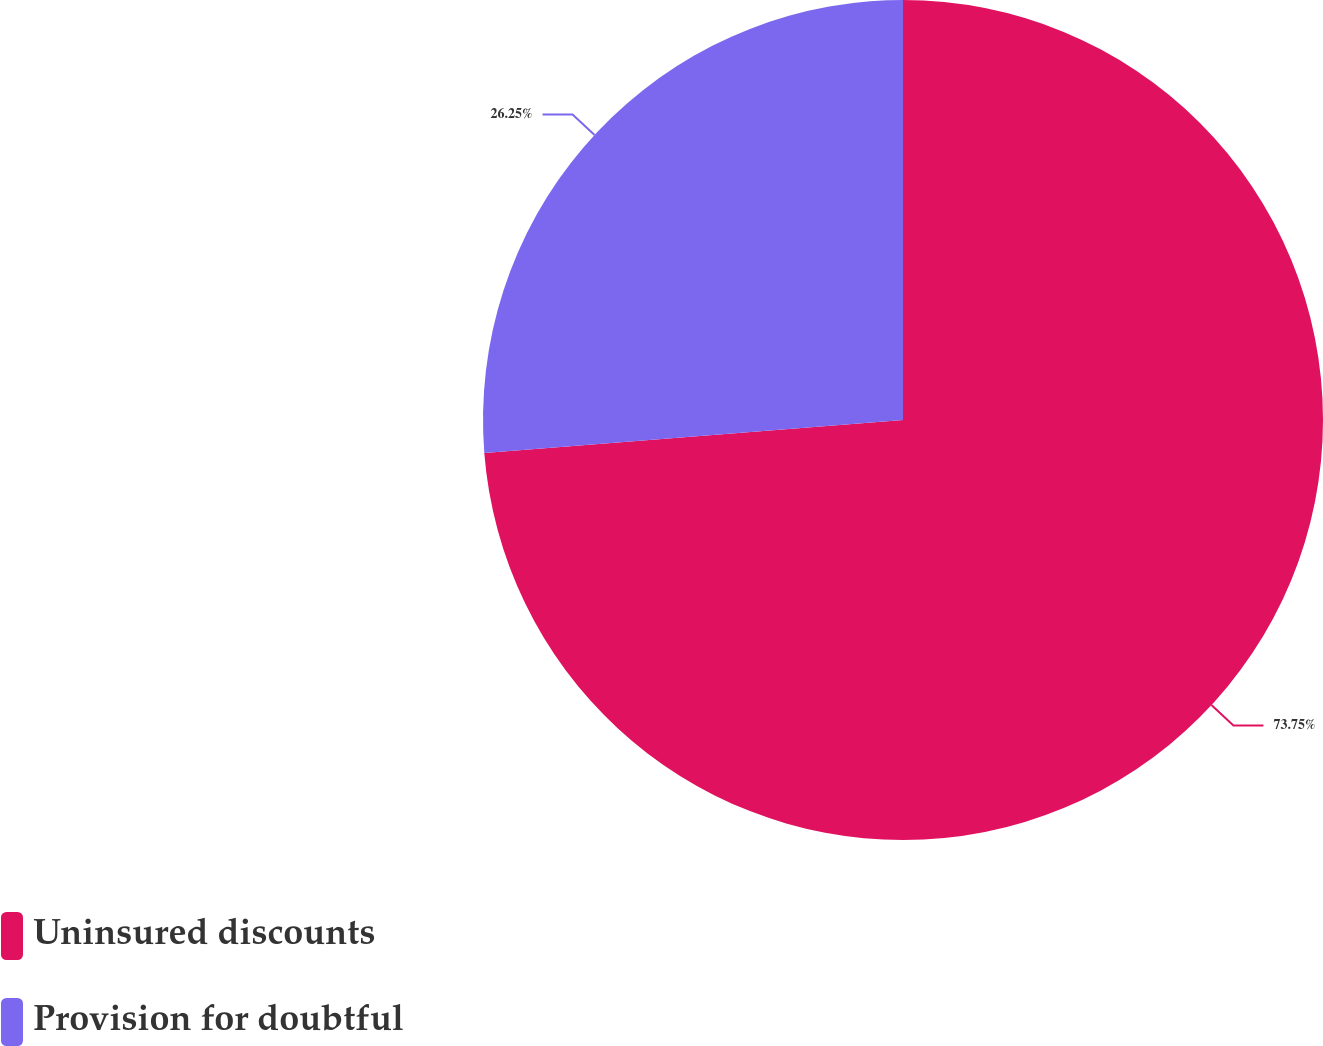Convert chart to OTSL. <chart><loc_0><loc_0><loc_500><loc_500><pie_chart><fcel>Uninsured discounts<fcel>Provision for doubtful<nl><fcel>73.75%<fcel>26.25%<nl></chart> 